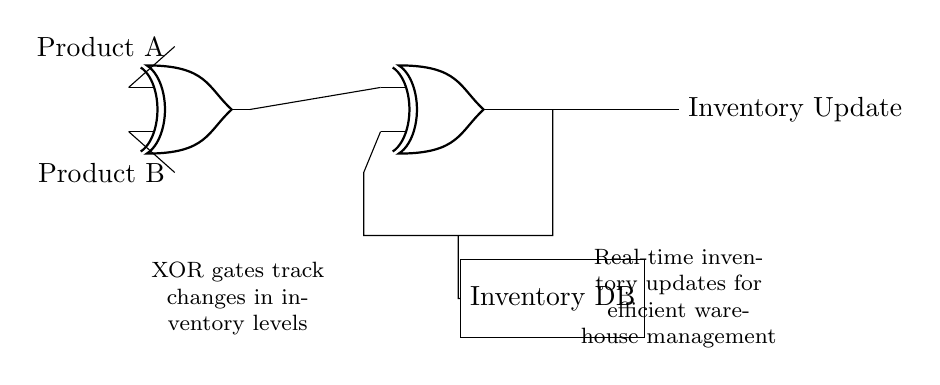What components are used in the circuit? The primary components used in the circuit are XOR gates and an inventory database block. The circuit includes two XOR gates that track changes in the inventory levels and a rectangular block labeled "Inventory DB".
Answer: XOR gates, Inventory DB How many XOR gates are present in the circuit? The diagram shows two distinct XOR gates connected in a series. They are visually represented side by side, with their inputs and outputs defined at different locations.
Answer: Two What is the purpose of the inventory database? The inventory database serves as a storage unit for updating and managing the inventory levels in real-time. It connects to one of the XOR gates, indicating that it receives changes to the inventory status based on the outputs of the gates.
Answer: Inventory management What inputs does the first XOR gate receive? The first XOR gate receives inputs from "Product A" and "Product B", indicated by labeled lines connecting these elements to the respective inputs of the gate. This setup implies it determines the difference in levels between these products.
Answer: Product A, Product B What type of logic operation is performed by the XOR gates in the circuit? XOR gates perform an exclusive OR operation, which outputs true (or high) only when an odd number of inputs are true (in this case, if one product's level changes, but not both). It is crucial for tracking discrepancies in inventory levels effectively.
Answer: Exclusive OR How does the feedback loop contribute to the circuit's operation? The feedback loop connects the output of the second XOR gate back to one of its inputs. This arrangement allows the system to effectively track ongoing changes in the inventory levels and adjust accordingly, enabling real-time updates.
Answer: Tracks changes 